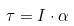<formula> <loc_0><loc_0><loc_500><loc_500>\tau = I \cdot \alpha</formula> 